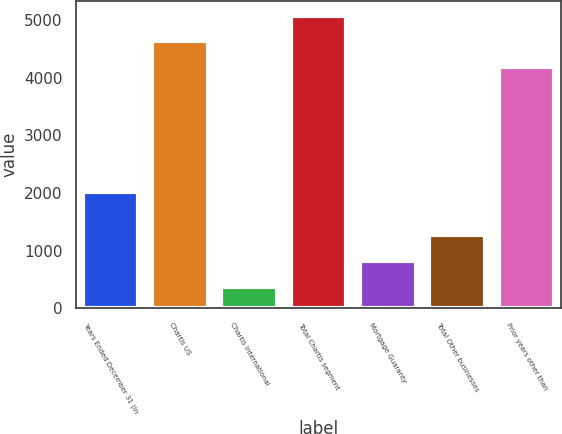Convert chart. <chart><loc_0><loc_0><loc_500><loc_500><bar_chart><fcel>Years Ended December 31 (in<fcel>Chartis US<fcel>Chartis International<fcel>Total Chartis segment<fcel>Mortgage Guaranty<fcel>Total Other businesses<fcel>Prior years other than<nl><fcel>2010<fcel>4629.1<fcel>379<fcel>5076.2<fcel>826.1<fcel>1273.2<fcel>4182<nl></chart> 